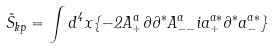Convert formula to latex. <formula><loc_0><loc_0><loc_500><loc_500>\tilde { S } _ { k p } = \int d ^ { 4 } x \{ - 2 A _ { + } ^ { a } \partial \partial ^ { * } A _ { - - } ^ { a } i a _ { + } ^ { a * } \partial ^ { * } a _ { - } ^ { a * } \}</formula> 